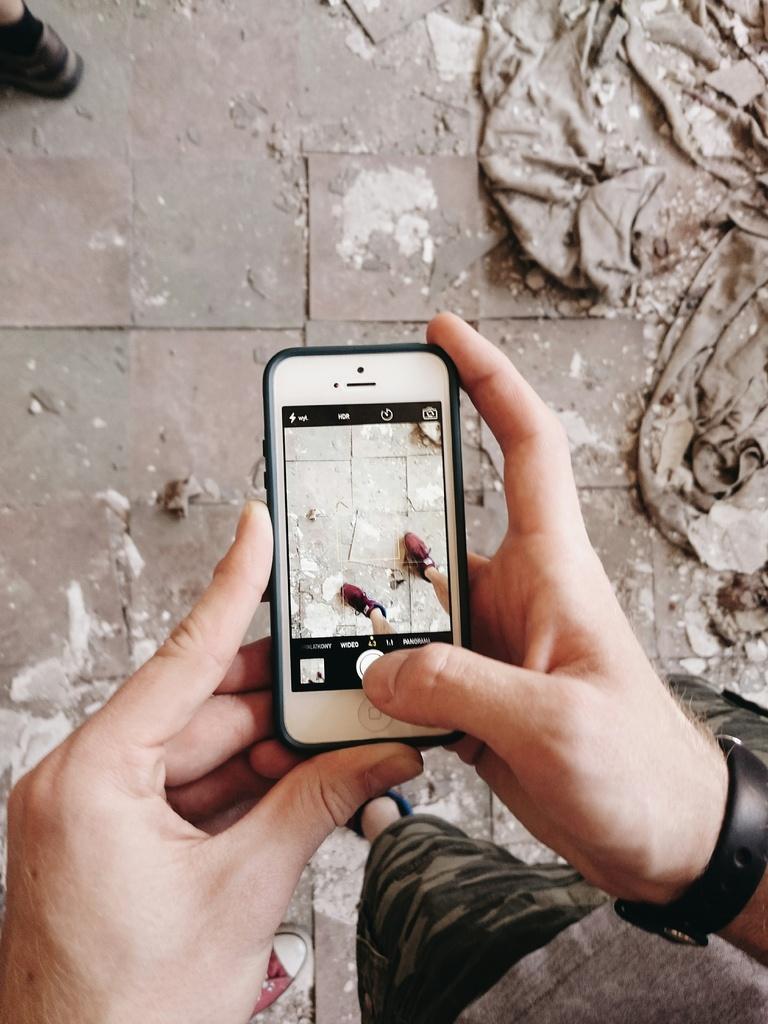Describe this image in one or two sentences. At the bottom portion of the picture we can see the floor, person leg and a cloth. In this picture we can see a person wearing a wrist watch and holding a camera, taking the snap. 